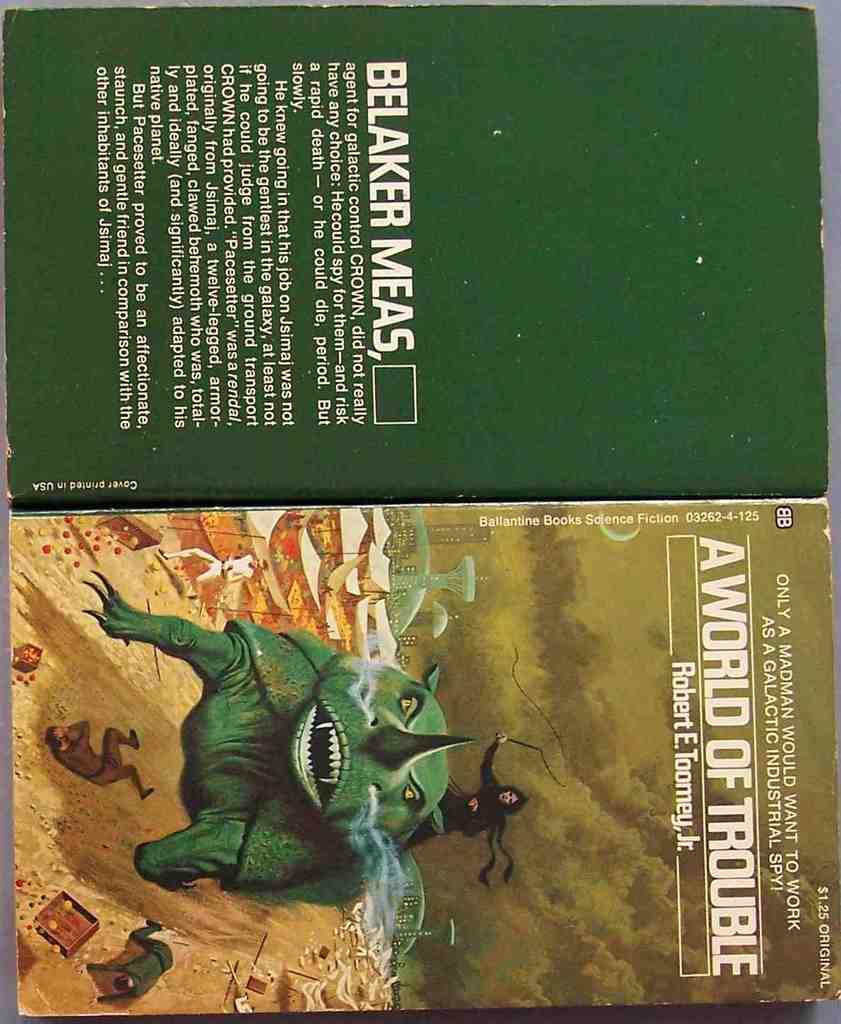Who is the author of this book?
Keep it short and to the point. Robert e toomey jr. Is this an old science fiction book?
Make the answer very short. Yes. 